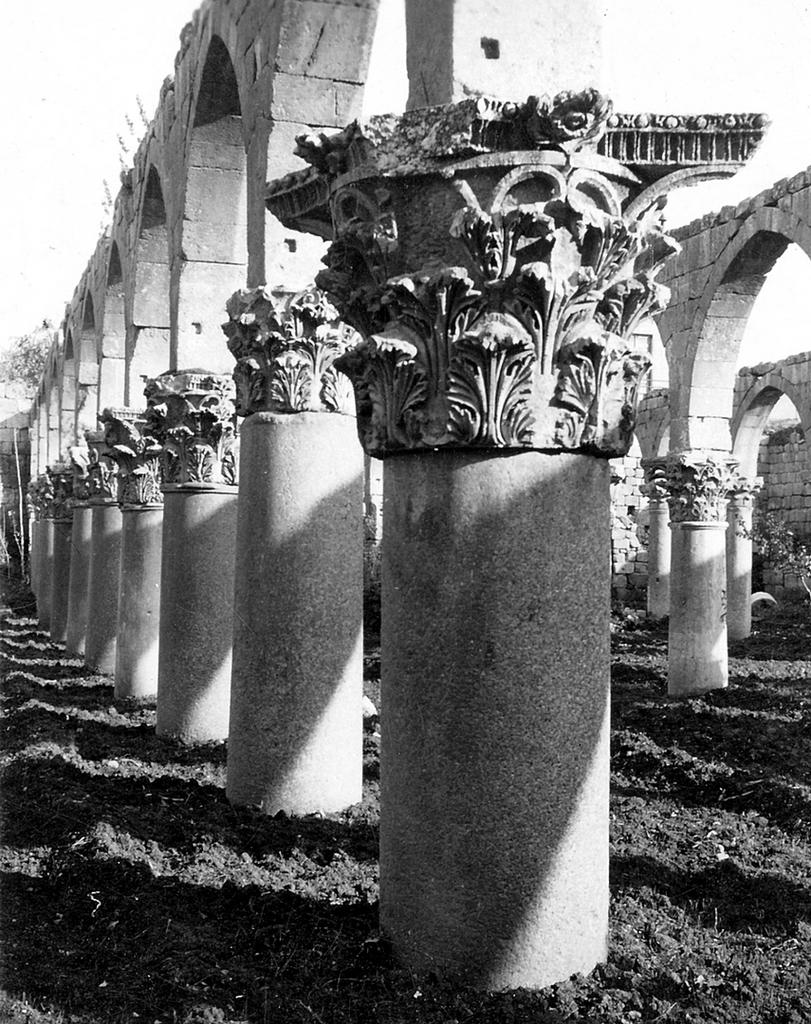What is the color scheme of the image? The image is black and white. What architectural features can be seen in the image? There are pillars and arches in the image. What type of natural elements are visible in the background of the image? There are trees visible in the background of the image. Can you tell me how many crooks are hiding behind the pillars in the image? There are no crooks present in the image; it features pillars and arches in a black and white color scheme. What type of chair is shown in the image? There is no chair present in the image. 